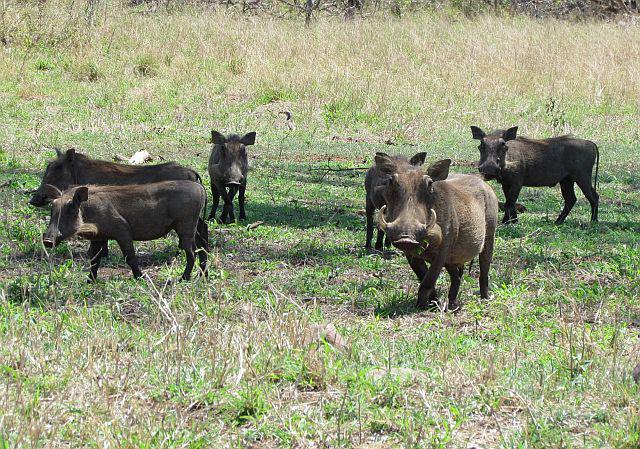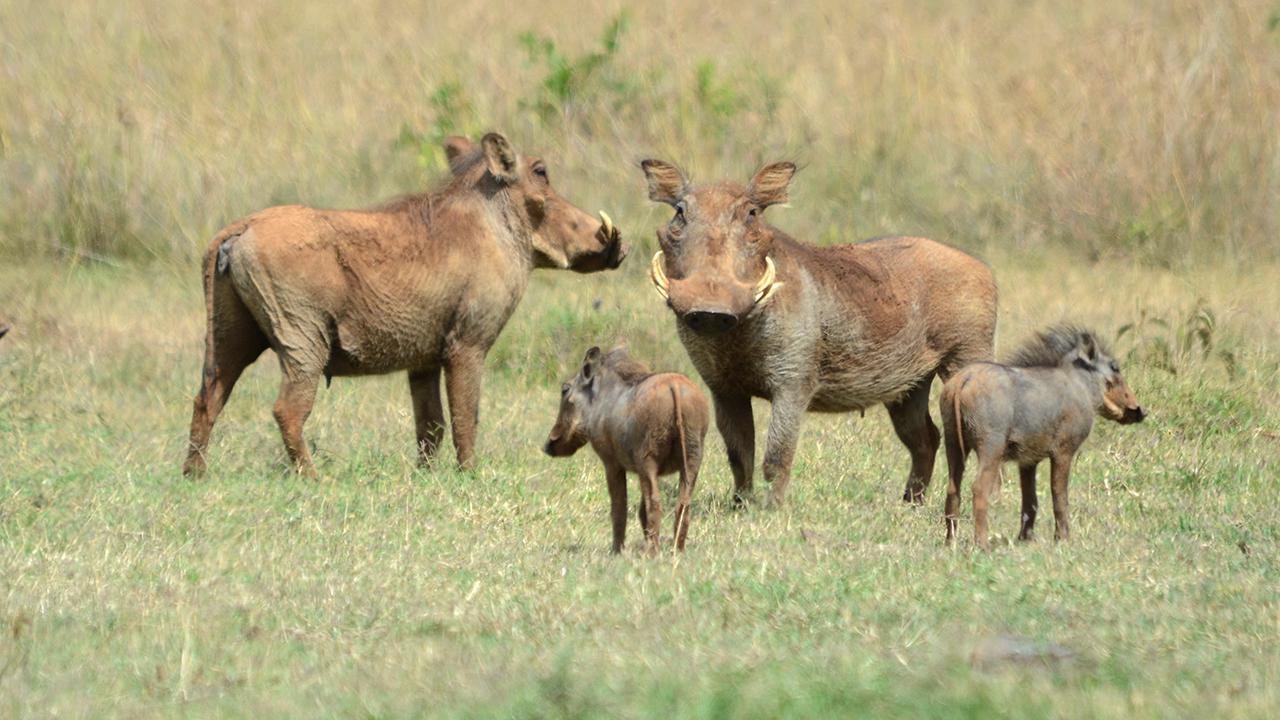The first image is the image on the left, the second image is the image on the right. For the images displayed, is the sentence "There are exactly 5 animals in the image on the right." factually correct? Answer yes or no. No. 